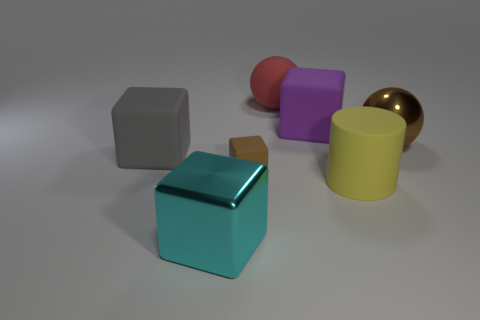Add 1 big blue cubes. How many objects exist? 8 Subtract all cubes. How many objects are left? 3 Subtract all tiny brown matte objects. Subtract all purple rubber cubes. How many objects are left? 5 Add 1 red rubber objects. How many red rubber objects are left? 2 Add 2 large purple things. How many large purple things exist? 3 Subtract 0 green cylinders. How many objects are left? 7 